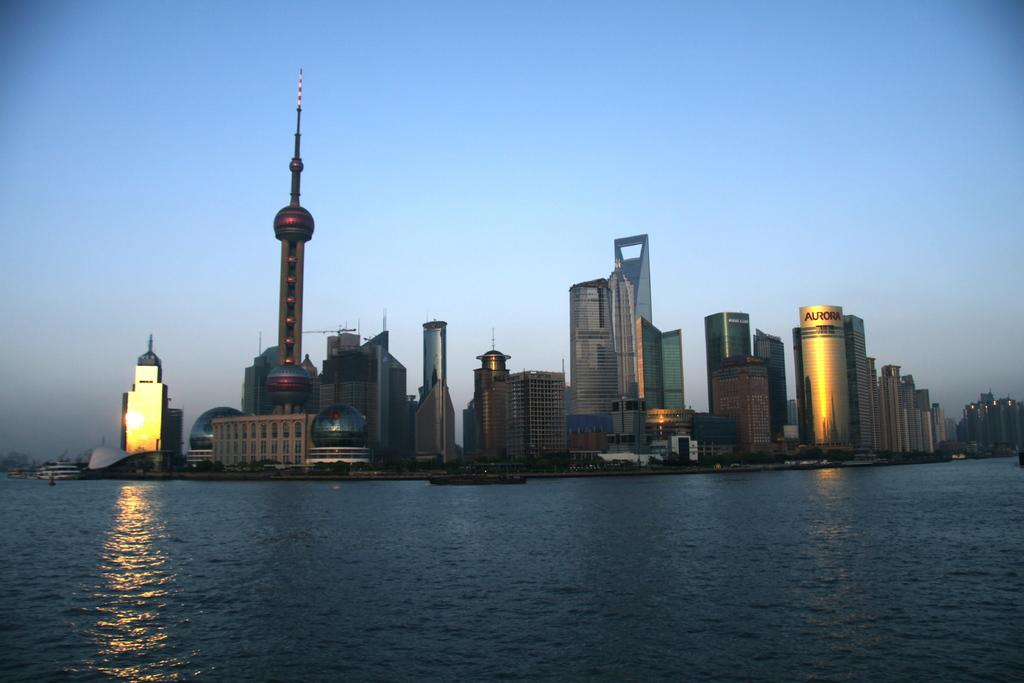What is located in front of the image? There is water in front of the image. What structures can be seen in the middle of the image? There are buildings in the middle of the image. What can be seen illuminating the scene in the image? There are lights visible in the image. What is the condition of the sky in the background of the image? The sky is clear in the background of the image. What type of underwear is hanging from the buildings in the image? There is no underwear present in the image; it features water, buildings, lights, and a clear sky. What riddle can be solved by looking at the image? There is no riddle associated with the image; it simply depicts water, buildings, lights, and a clear sky. 